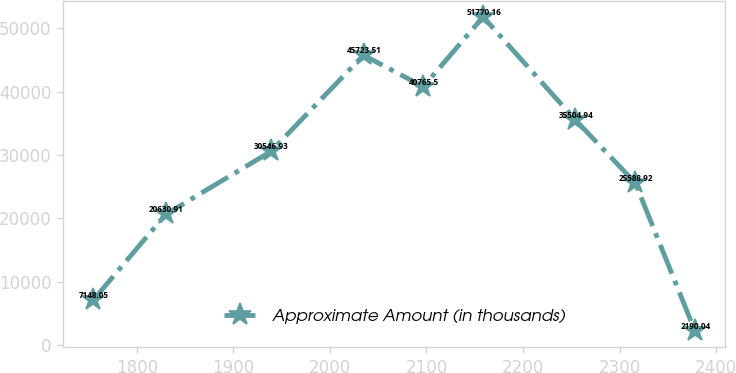Convert chart to OTSL. <chart><loc_0><loc_0><loc_500><loc_500><line_chart><ecel><fcel>Approximate Amount (in thousands)<nl><fcel>1754.98<fcel>7148.05<nl><fcel>1829.9<fcel>20630.9<nl><fcel>1938.86<fcel>30546.9<nl><fcel>2034.83<fcel>45723.5<nl><fcel>2096.78<fcel>40765.5<nl><fcel>2158.73<fcel>51770.2<nl><fcel>2254.39<fcel>35504.9<nl><fcel>2316.34<fcel>25588.9<nl><fcel>2378.29<fcel>2190.04<nl></chart> 